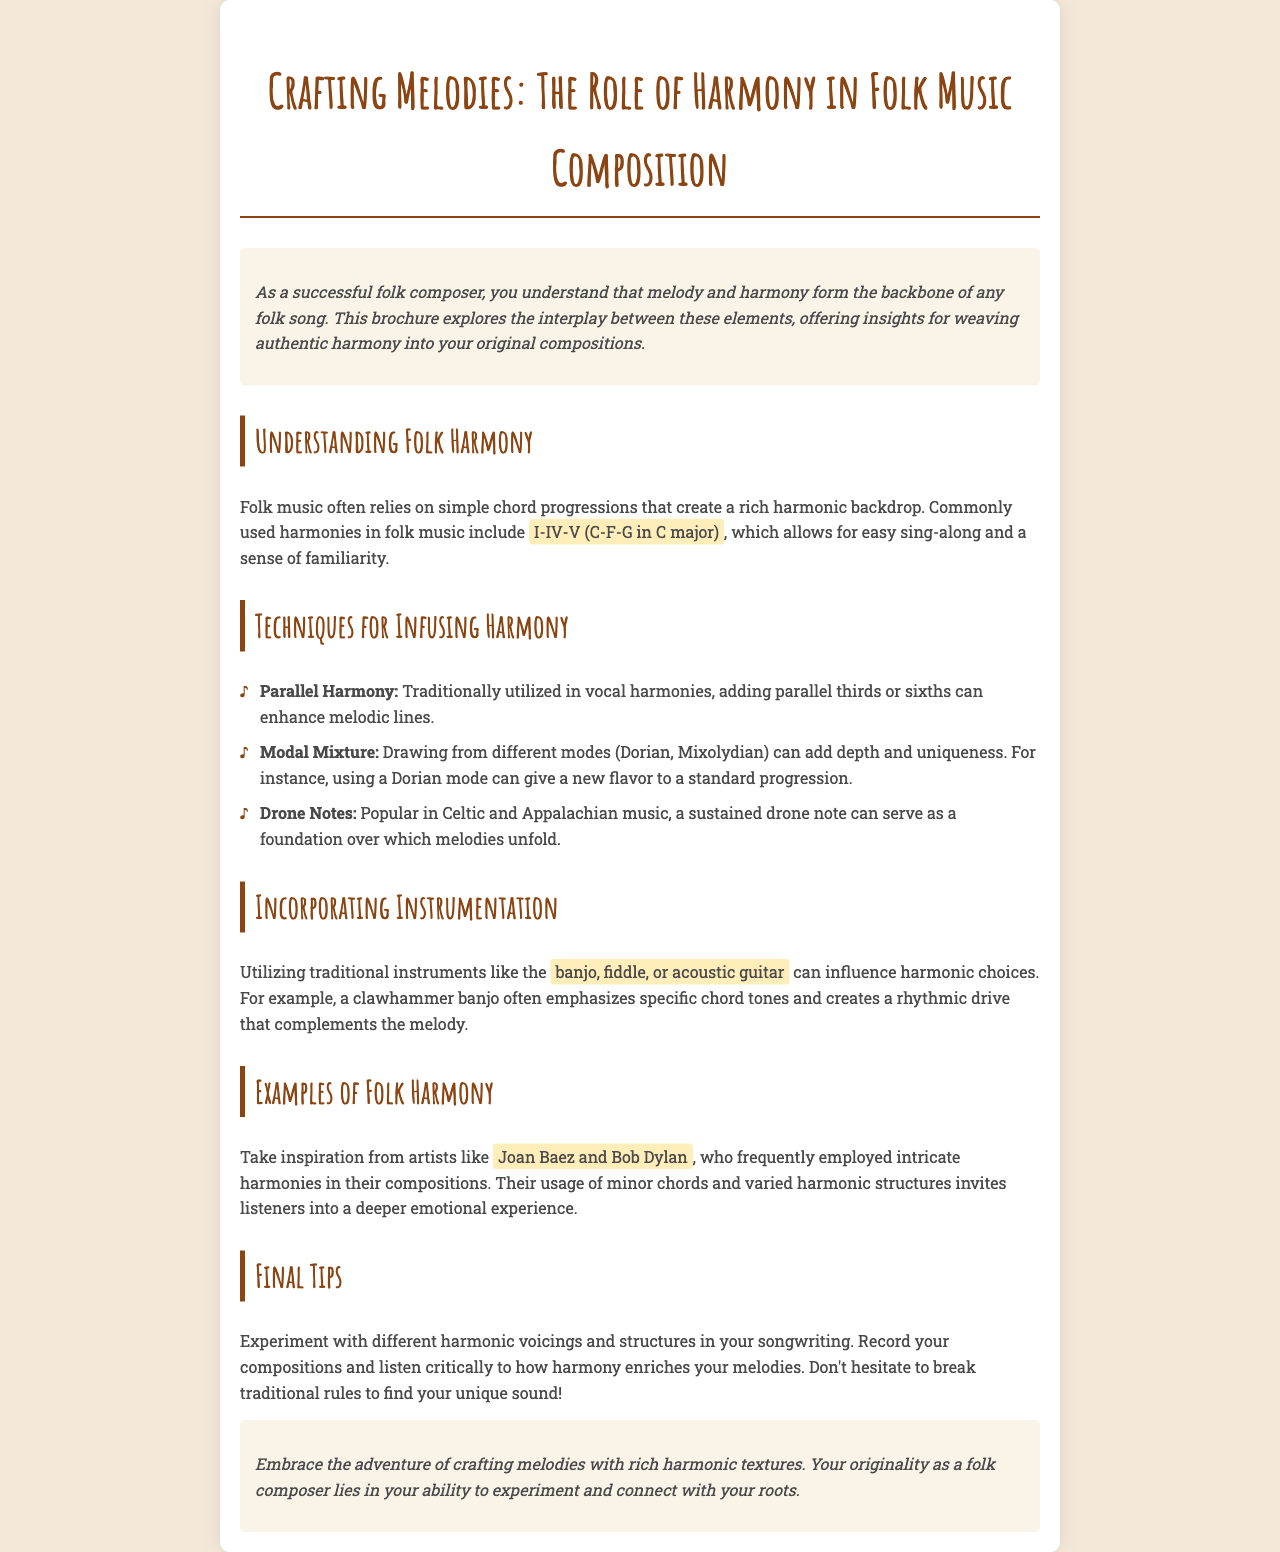What is the title of the brochure? The title is explicitly stated in the document as the main heading.
Answer: Crafting Melodies: The Role of Harmony in Folk Music Composition What are the common chord progressions mentioned? The document lists specific chord progressions used in folk music.
Answer: I-IV-V (C-F-G in C major) Name a technique for infusing harmony. Techniques listed in the document highlight ways to enrich harmony.
Answer: Parallel Harmony Which instruments are suggested to influence harmonic choices? The document specifically mentions traditional instruments that can impact harmony.
Answer: banjo, fiddle, or acoustic guitar Who are two artists mentioned as examples of folk harmony? The brochure provides examples of musicians known for their harmonious compositions.
Answer: Joan Baez and Bob Dylan What is a benefit of utilizing drone notes? The document explains how drone notes are used in music.
Answer: A sustained drone note can serve as a foundation What should you do to find your unique sound? The brochure emphasizes the importance of experimentation in songwriting.
Answer: Break traditional rules What type of music prominently features drone notes? The document specifies genres known for using drone notes.
Answer: Celtic and Appalachian music 